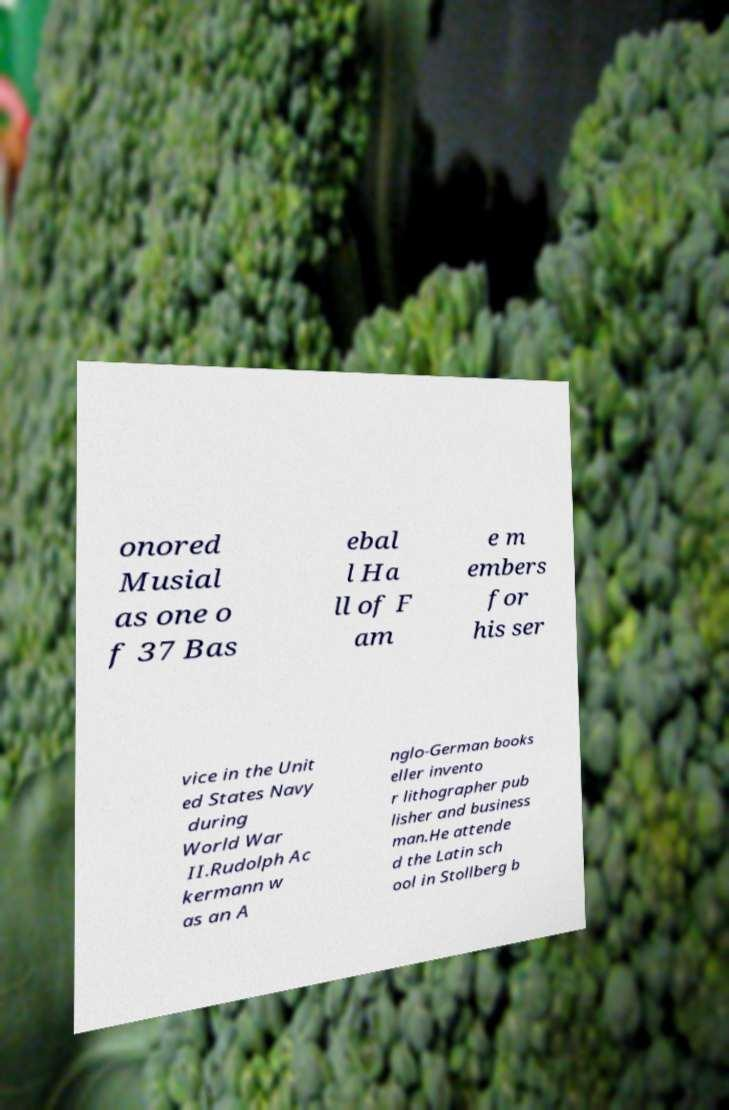What messages or text are displayed in this image? I need them in a readable, typed format. onored Musial as one o f 37 Bas ebal l Ha ll of F am e m embers for his ser vice in the Unit ed States Navy during World War II.Rudolph Ac kermann w as an A nglo-German books eller invento r lithographer pub lisher and business man.He attende d the Latin sch ool in Stollberg b 